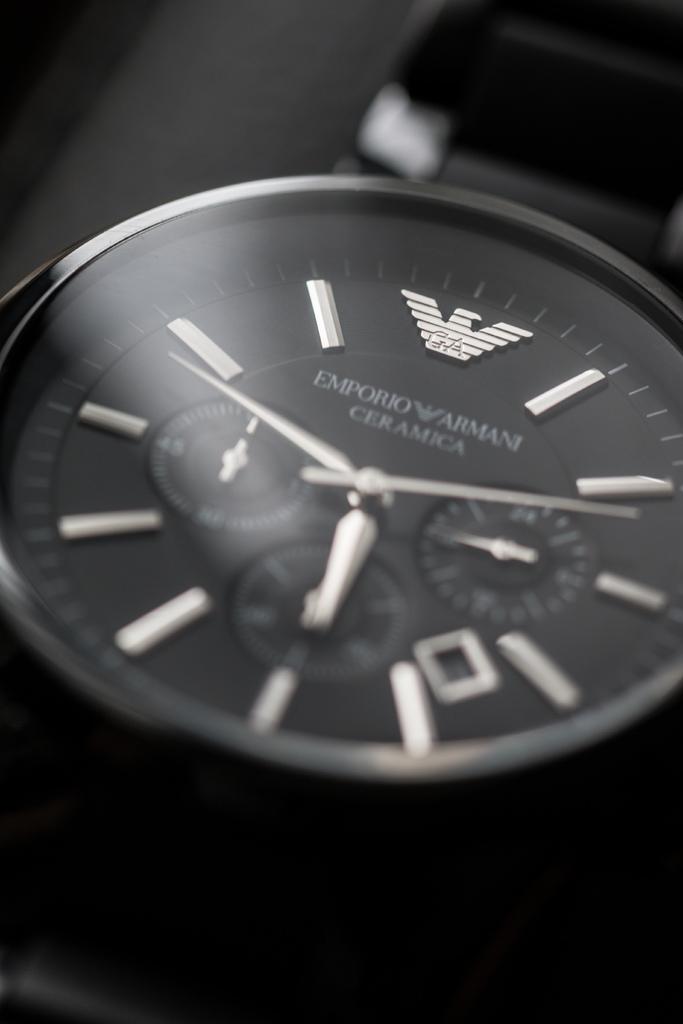What is the brand of the watch?
Give a very brief answer. Emporio armani. 